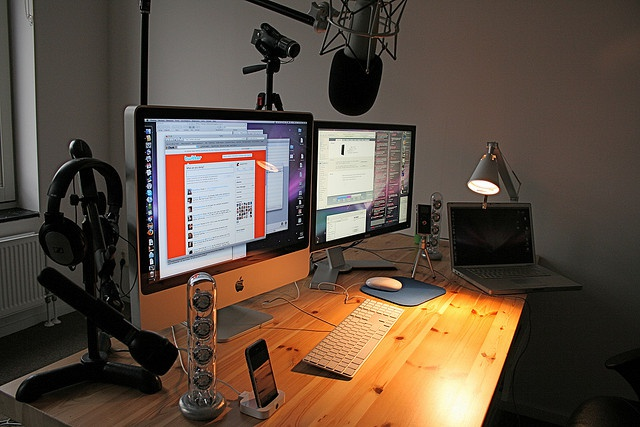Describe the objects in this image and their specific colors. I can see tv in black, lightgray, red, and lightblue tones, tv in black, beige, gray, and darkgray tones, laptop in black, maroon, and gray tones, keyboard in black, tan, brown, and salmon tones, and keyboard in black, maroon, and brown tones in this image. 